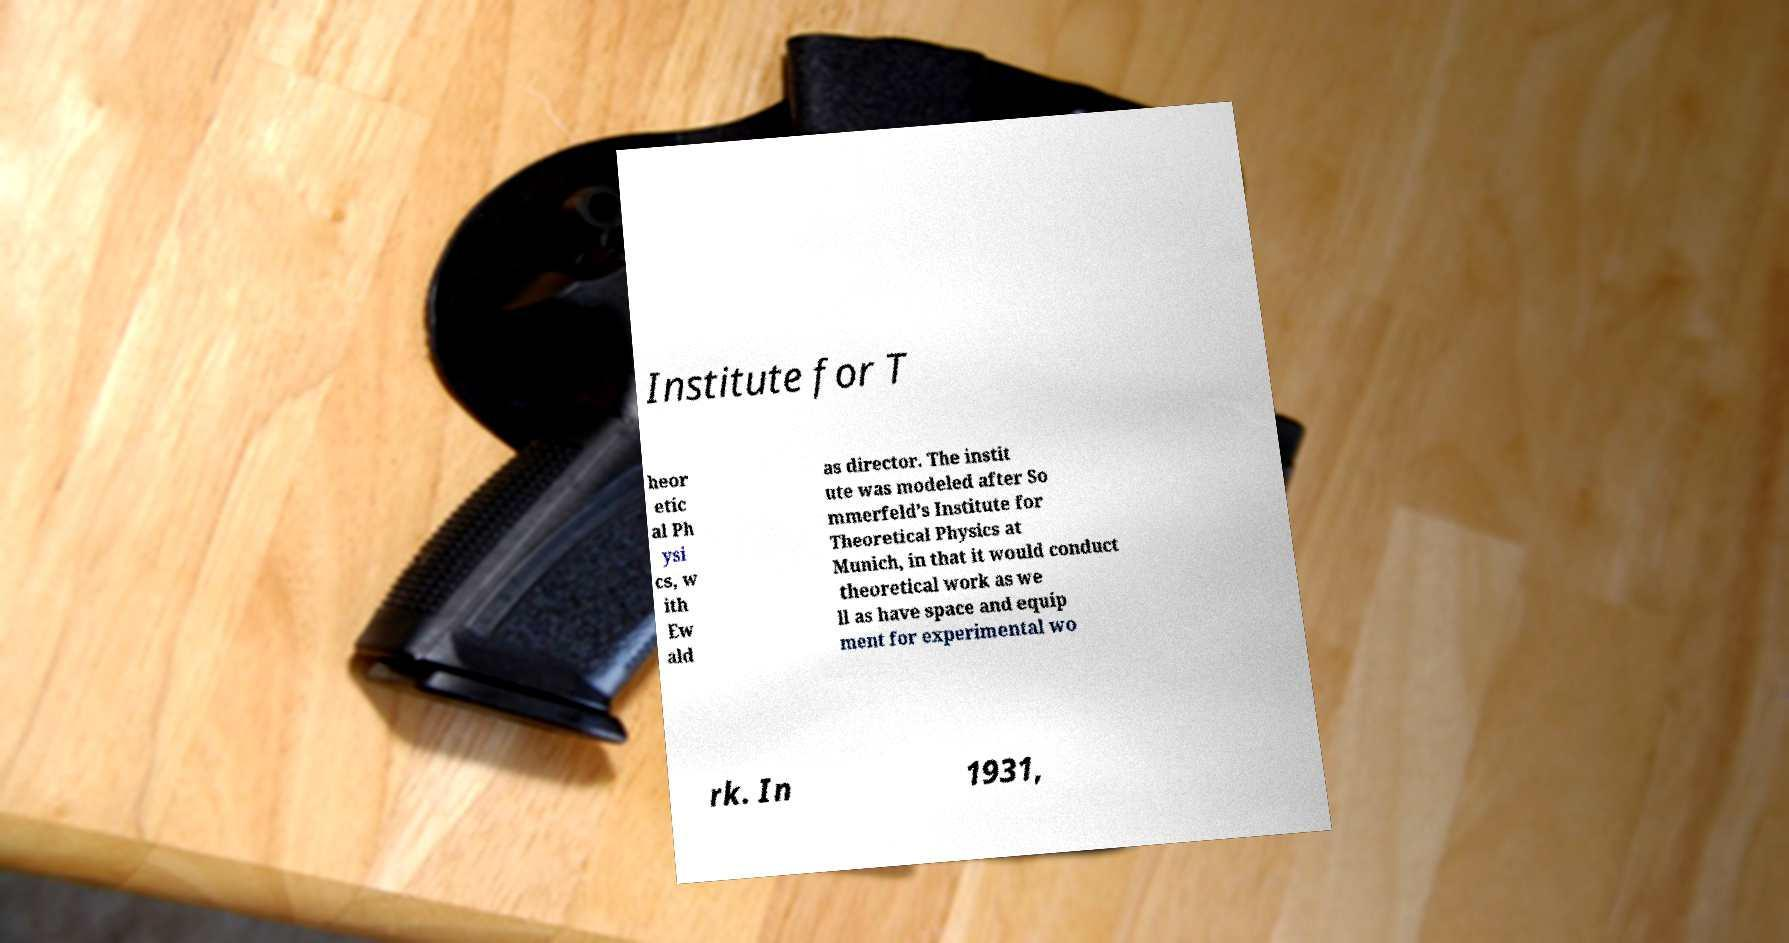Please read and relay the text visible in this image. What does it say? Institute for T heor etic al Ph ysi cs, w ith Ew ald as director. The instit ute was modeled after So mmerfeld’s Institute for Theoretical Physics at Munich, in that it would conduct theoretical work as we ll as have space and equip ment for experimental wo rk. In 1931, 